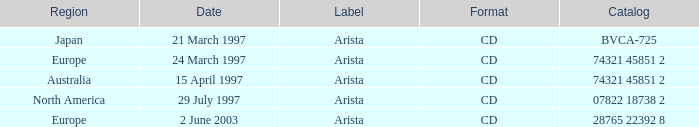What can be found on the label with a date of 29th july 1997? Arista. 